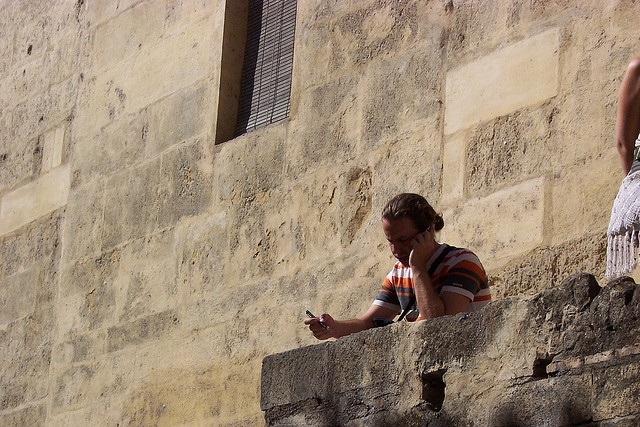Describe the objects in this image and their specific colors. I can see people in lightgray, black, maroon, gray, and brown tones, people in lightgray, darkgray, maroon, and black tones, and cell phone in black, gray, and lightgray tones in this image. 